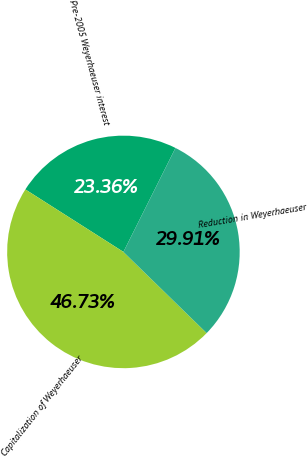<chart> <loc_0><loc_0><loc_500><loc_500><pie_chart><fcel>Pre-2005 Weyerhaeuser interest<fcel>Capitalization of Weyerhaeuser<fcel>Reduction in Weyerhaeuser<nl><fcel>23.36%<fcel>46.73%<fcel>29.91%<nl></chart> 